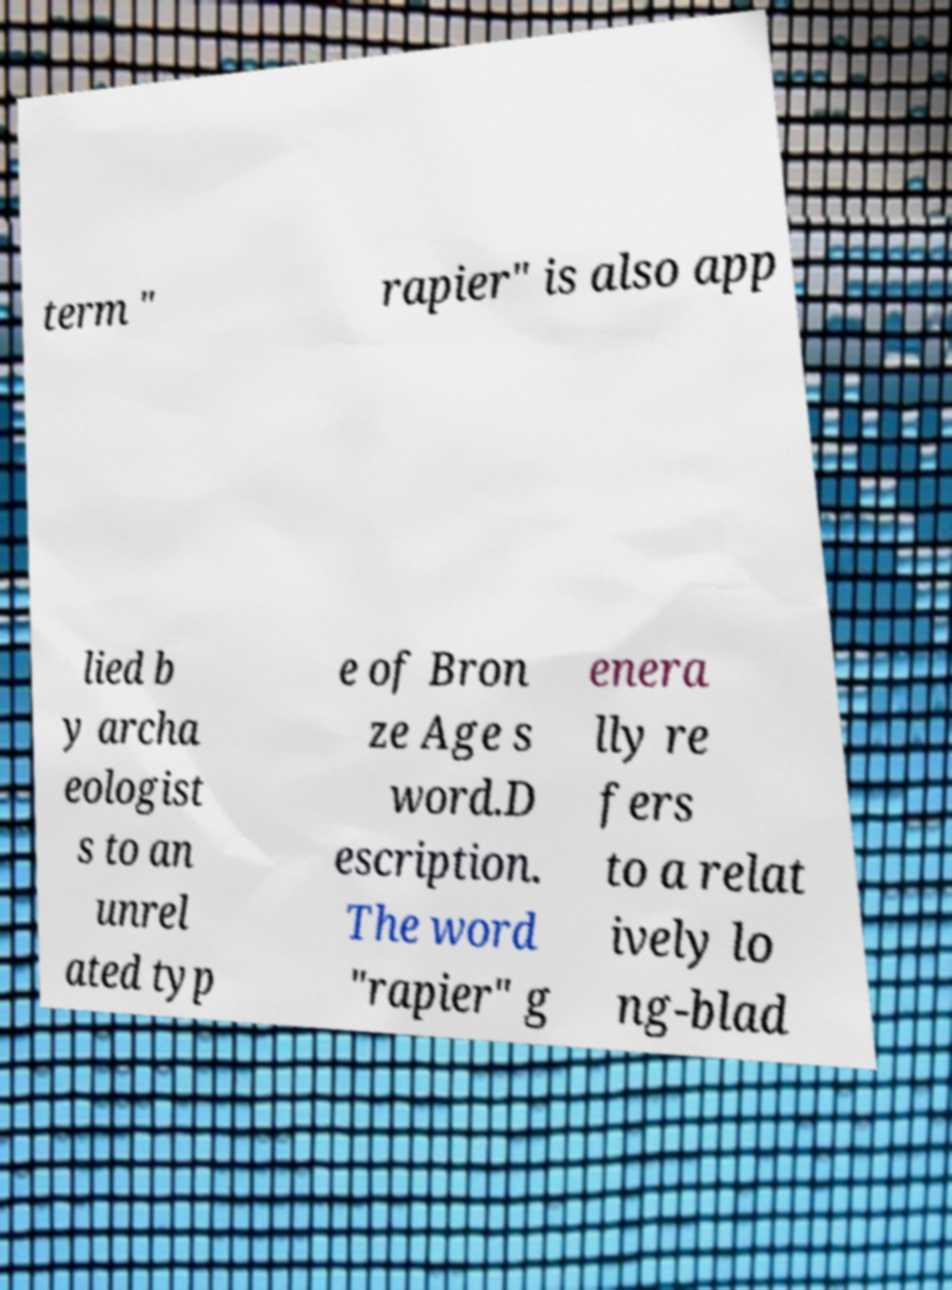For documentation purposes, I need the text within this image transcribed. Could you provide that? term " rapier" is also app lied b y archa eologist s to an unrel ated typ e of Bron ze Age s word.D escription. The word "rapier" g enera lly re fers to a relat ively lo ng-blad 